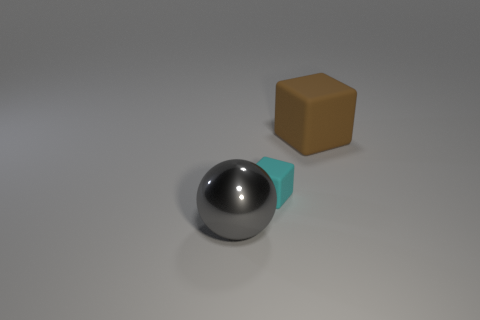Subtract all cubes. How many objects are left? 1 Subtract all cyan cubes. How many cubes are left? 1 Add 2 brown matte objects. How many brown matte objects are left? 3 Add 3 cyan rubber cubes. How many cyan rubber cubes exist? 4 Add 1 large gray metallic spheres. How many objects exist? 4 Subtract 0 red balls. How many objects are left? 3 Subtract 1 spheres. How many spheres are left? 0 Subtract all red spheres. Subtract all purple cubes. How many spheres are left? 1 Subtract all yellow cylinders. How many brown blocks are left? 1 Subtract all big gray things. Subtract all large things. How many objects are left? 0 